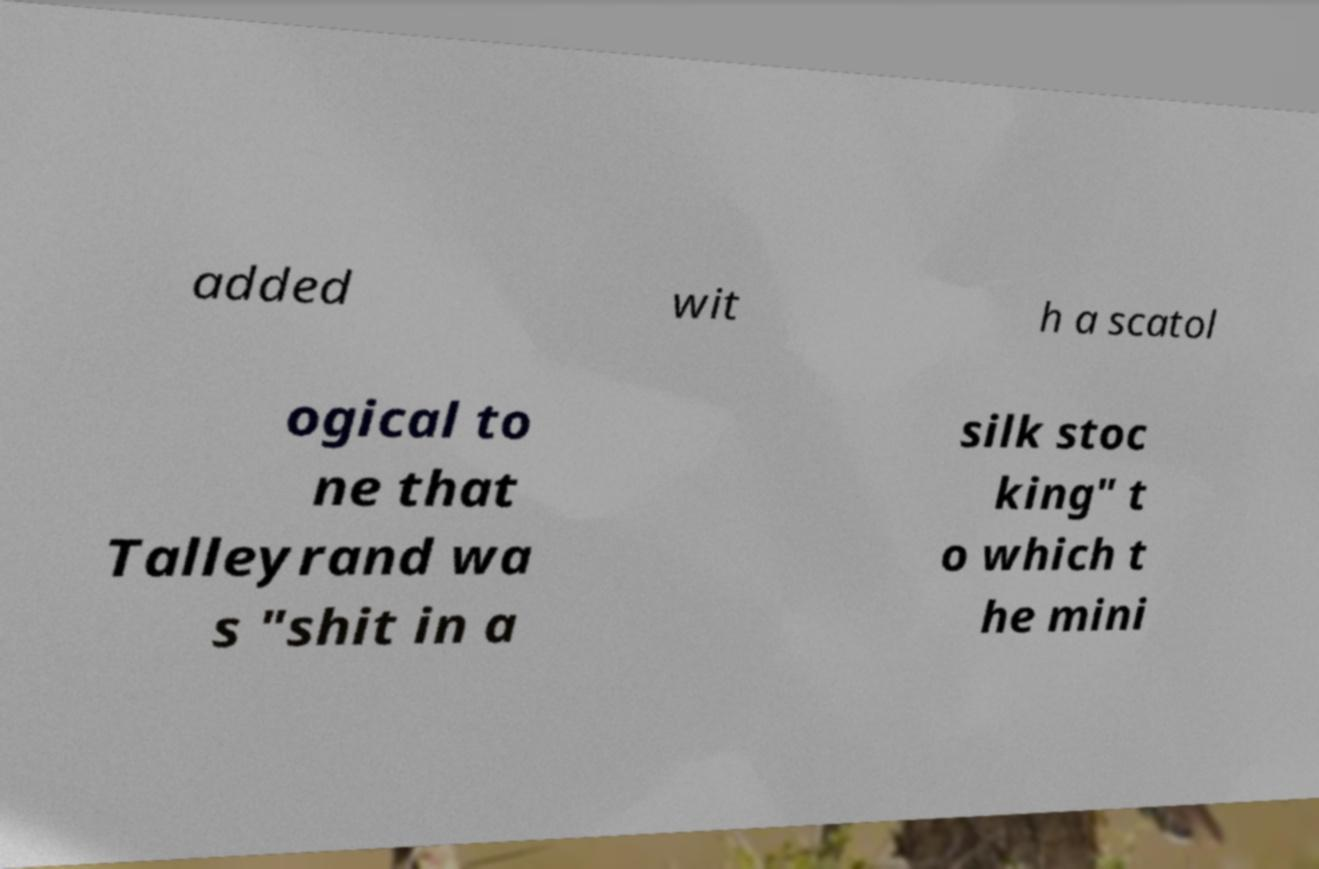I need the written content from this picture converted into text. Can you do that? added wit h a scatol ogical to ne that Talleyrand wa s "shit in a silk stoc king" t o which t he mini 